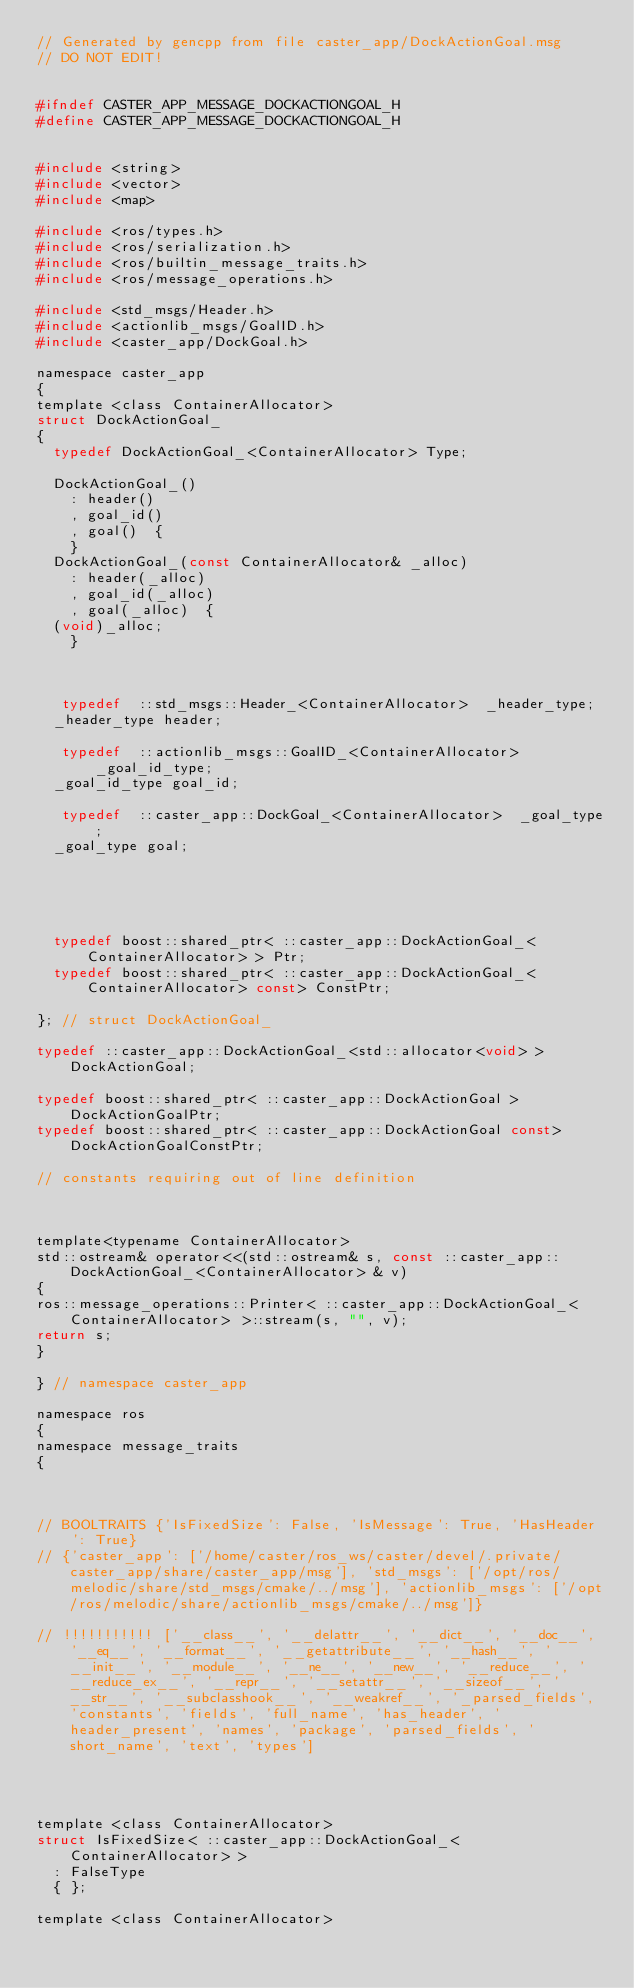Convert code to text. <code><loc_0><loc_0><loc_500><loc_500><_C_>// Generated by gencpp from file caster_app/DockActionGoal.msg
// DO NOT EDIT!


#ifndef CASTER_APP_MESSAGE_DOCKACTIONGOAL_H
#define CASTER_APP_MESSAGE_DOCKACTIONGOAL_H


#include <string>
#include <vector>
#include <map>

#include <ros/types.h>
#include <ros/serialization.h>
#include <ros/builtin_message_traits.h>
#include <ros/message_operations.h>

#include <std_msgs/Header.h>
#include <actionlib_msgs/GoalID.h>
#include <caster_app/DockGoal.h>

namespace caster_app
{
template <class ContainerAllocator>
struct DockActionGoal_
{
  typedef DockActionGoal_<ContainerAllocator> Type;

  DockActionGoal_()
    : header()
    , goal_id()
    , goal()  {
    }
  DockActionGoal_(const ContainerAllocator& _alloc)
    : header(_alloc)
    , goal_id(_alloc)
    , goal(_alloc)  {
  (void)_alloc;
    }



   typedef  ::std_msgs::Header_<ContainerAllocator>  _header_type;
  _header_type header;

   typedef  ::actionlib_msgs::GoalID_<ContainerAllocator>  _goal_id_type;
  _goal_id_type goal_id;

   typedef  ::caster_app::DockGoal_<ContainerAllocator>  _goal_type;
  _goal_type goal;





  typedef boost::shared_ptr< ::caster_app::DockActionGoal_<ContainerAllocator> > Ptr;
  typedef boost::shared_ptr< ::caster_app::DockActionGoal_<ContainerAllocator> const> ConstPtr;

}; // struct DockActionGoal_

typedef ::caster_app::DockActionGoal_<std::allocator<void> > DockActionGoal;

typedef boost::shared_ptr< ::caster_app::DockActionGoal > DockActionGoalPtr;
typedef boost::shared_ptr< ::caster_app::DockActionGoal const> DockActionGoalConstPtr;

// constants requiring out of line definition



template<typename ContainerAllocator>
std::ostream& operator<<(std::ostream& s, const ::caster_app::DockActionGoal_<ContainerAllocator> & v)
{
ros::message_operations::Printer< ::caster_app::DockActionGoal_<ContainerAllocator> >::stream(s, "", v);
return s;
}

} // namespace caster_app

namespace ros
{
namespace message_traits
{



// BOOLTRAITS {'IsFixedSize': False, 'IsMessage': True, 'HasHeader': True}
// {'caster_app': ['/home/caster/ros_ws/caster/devel/.private/caster_app/share/caster_app/msg'], 'std_msgs': ['/opt/ros/melodic/share/std_msgs/cmake/../msg'], 'actionlib_msgs': ['/opt/ros/melodic/share/actionlib_msgs/cmake/../msg']}

// !!!!!!!!!!! ['__class__', '__delattr__', '__dict__', '__doc__', '__eq__', '__format__', '__getattribute__', '__hash__', '__init__', '__module__', '__ne__', '__new__', '__reduce__', '__reduce_ex__', '__repr__', '__setattr__', '__sizeof__', '__str__', '__subclasshook__', '__weakref__', '_parsed_fields', 'constants', 'fields', 'full_name', 'has_header', 'header_present', 'names', 'package', 'parsed_fields', 'short_name', 'text', 'types']




template <class ContainerAllocator>
struct IsFixedSize< ::caster_app::DockActionGoal_<ContainerAllocator> >
  : FalseType
  { };

template <class ContainerAllocator></code> 